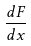<formula> <loc_0><loc_0><loc_500><loc_500>\frac { d F } { d x }</formula> 